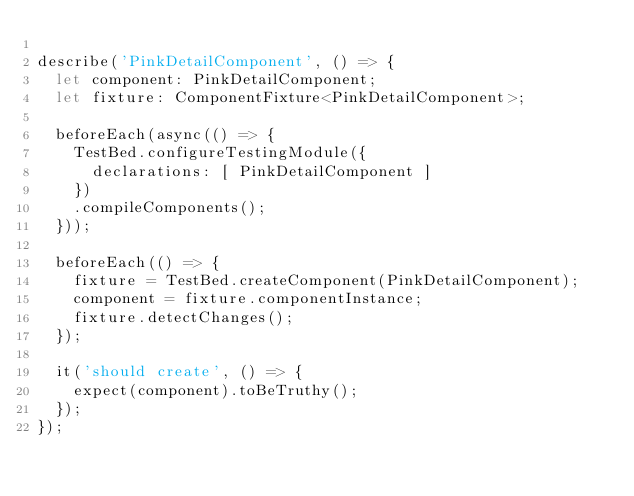<code> <loc_0><loc_0><loc_500><loc_500><_TypeScript_>
describe('PinkDetailComponent', () => {
  let component: PinkDetailComponent;
  let fixture: ComponentFixture<PinkDetailComponent>;

  beforeEach(async(() => {
    TestBed.configureTestingModule({
      declarations: [ PinkDetailComponent ]
    })
    .compileComponents();
  }));

  beforeEach(() => {
    fixture = TestBed.createComponent(PinkDetailComponent);
    component = fixture.componentInstance;
    fixture.detectChanges();
  });

  it('should create', () => {
    expect(component).toBeTruthy();
  });
});
</code> 